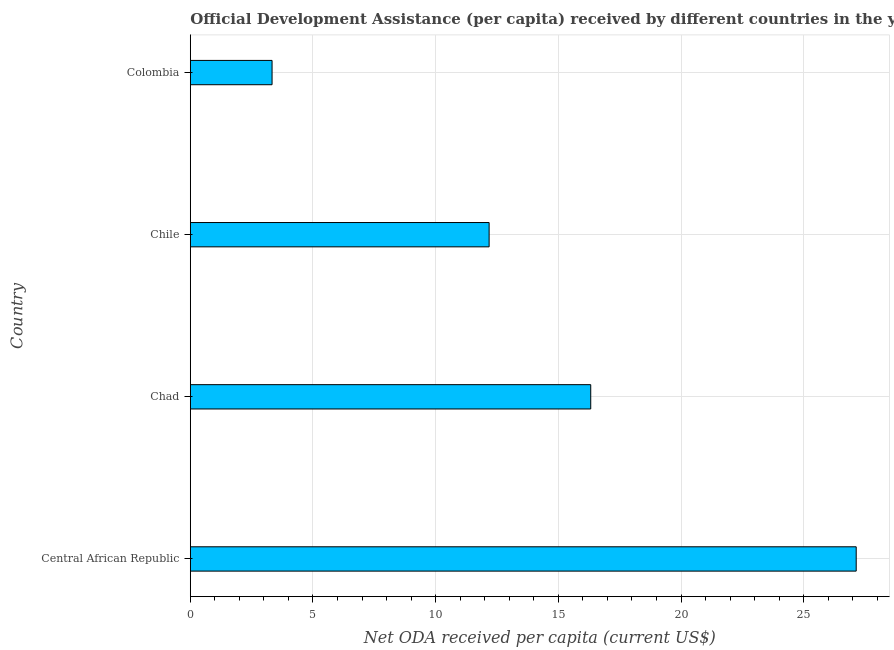What is the title of the graph?
Provide a short and direct response. Official Development Assistance (per capita) received by different countries in the year 1975. What is the label or title of the X-axis?
Your answer should be very brief. Net ODA received per capita (current US$). What is the net oda received per capita in Colombia?
Provide a short and direct response. 3.33. Across all countries, what is the maximum net oda received per capita?
Your answer should be very brief. 27.14. Across all countries, what is the minimum net oda received per capita?
Offer a terse response. 3.33. In which country was the net oda received per capita maximum?
Make the answer very short. Central African Republic. In which country was the net oda received per capita minimum?
Your answer should be compact. Colombia. What is the sum of the net oda received per capita?
Provide a succinct answer. 58.97. What is the difference between the net oda received per capita in Central African Republic and Chile?
Provide a short and direct response. 14.96. What is the average net oda received per capita per country?
Make the answer very short. 14.74. What is the median net oda received per capita?
Your response must be concise. 14.25. What is the ratio of the net oda received per capita in Central African Republic to that in Chile?
Keep it short and to the point. 2.23. Is the net oda received per capita in Chad less than that in Chile?
Keep it short and to the point. No. What is the difference between the highest and the second highest net oda received per capita?
Provide a succinct answer. 10.82. What is the difference between the highest and the lowest net oda received per capita?
Ensure brevity in your answer.  23.81. Are all the bars in the graph horizontal?
Give a very brief answer. Yes. What is the difference between two consecutive major ticks on the X-axis?
Offer a very short reply. 5. What is the Net ODA received per capita (current US$) of Central African Republic?
Your response must be concise. 27.14. What is the Net ODA received per capita (current US$) in Chad?
Provide a succinct answer. 16.32. What is the Net ODA received per capita (current US$) of Chile?
Your answer should be very brief. 12.18. What is the Net ODA received per capita (current US$) of Colombia?
Provide a short and direct response. 3.33. What is the difference between the Net ODA received per capita (current US$) in Central African Republic and Chad?
Provide a short and direct response. 10.82. What is the difference between the Net ODA received per capita (current US$) in Central African Republic and Chile?
Provide a succinct answer. 14.96. What is the difference between the Net ODA received per capita (current US$) in Central African Republic and Colombia?
Provide a succinct answer. 23.81. What is the difference between the Net ODA received per capita (current US$) in Chad and Chile?
Make the answer very short. 4.14. What is the difference between the Net ODA received per capita (current US$) in Chad and Colombia?
Keep it short and to the point. 12.99. What is the difference between the Net ODA received per capita (current US$) in Chile and Colombia?
Provide a succinct answer. 8.85. What is the ratio of the Net ODA received per capita (current US$) in Central African Republic to that in Chad?
Give a very brief answer. 1.66. What is the ratio of the Net ODA received per capita (current US$) in Central African Republic to that in Chile?
Provide a short and direct response. 2.23. What is the ratio of the Net ODA received per capita (current US$) in Central African Republic to that in Colombia?
Ensure brevity in your answer.  8.14. What is the ratio of the Net ODA received per capita (current US$) in Chad to that in Chile?
Ensure brevity in your answer.  1.34. What is the ratio of the Net ODA received per capita (current US$) in Chad to that in Colombia?
Make the answer very short. 4.9. What is the ratio of the Net ODA received per capita (current US$) in Chile to that in Colombia?
Provide a succinct answer. 3.65. 